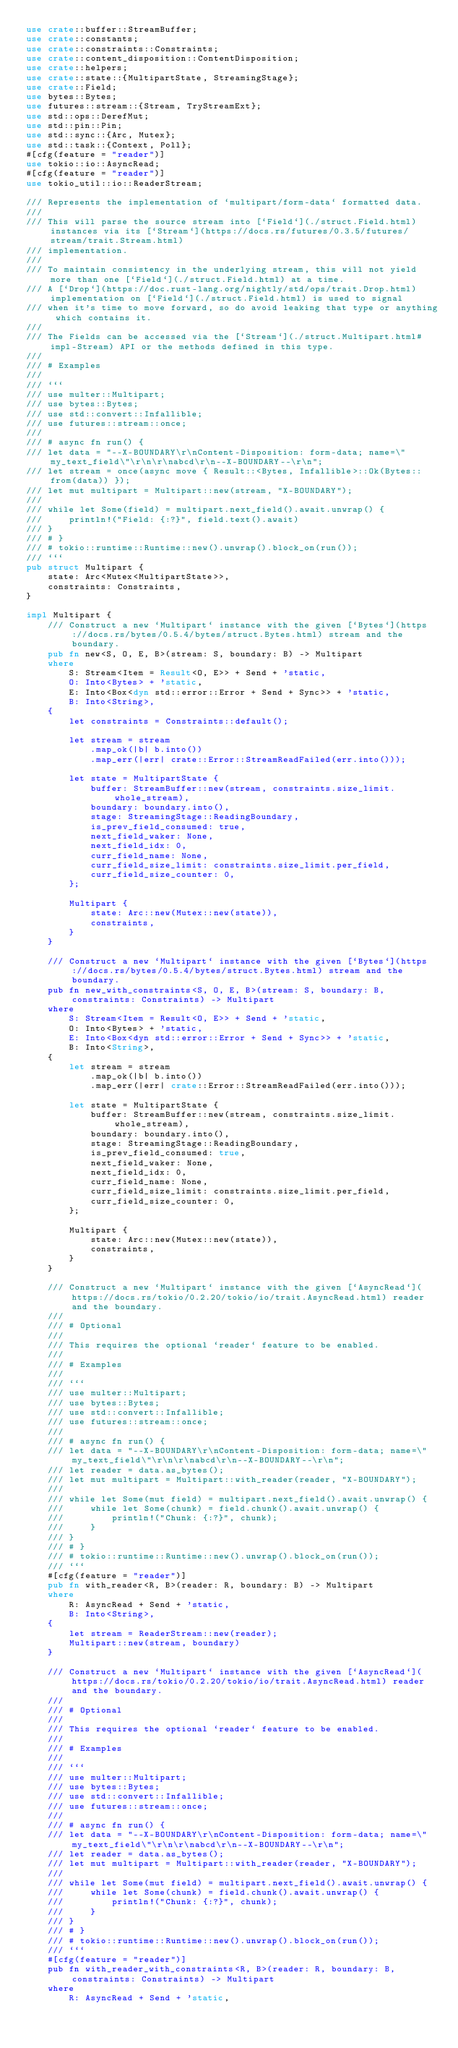<code> <loc_0><loc_0><loc_500><loc_500><_Rust_>use crate::buffer::StreamBuffer;
use crate::constants;
use crate::constraints::Constraints;
use crate::content_disposition::ContentDisposition;
use crate::helpers;
use crate::state::{MultipartState, StreamingStage};
use crate::Field;
use bytes::Bytes;
use futures::stream::{Stream, TryStreamExt};
use std::ops::DerefMut;
use std::pin::Pin;
use std::sync::{Arc, Mutex};
use std::task::{Context, Poll};
#[cfg(feature = "reader")]
use tokio::io::AsyncRead;
#[cfg(feature = "reader")]
use tokio_util::io::ReaderStream;

/// Represents the implementation of `multipart/form-data` formatted data.
///
/// This will parse the source stream into [`Field`](./struct.Field.html) instances via its [`Stream`](https://docs.rs/futures/0.3.5/futures/stream/trait.Stream.html)
/// implementation.
///
/// To maintain consistency in the underlying stream, this will not yield more than one [`Field`](./struct.Field.html) at a time.
/// A [`Drop`](https://doc.rust-lang.org/nightly/std/ops/trait.Drop.html) implementation on [`Field`](./struct.Field.html) is used to signal
/// when it's time to move forward, so do avoid leaking that type or anything which contains it.
///
/// The Fields can be accessed via the [`Stream`](./struct.Multipart.html#impl-Stream) API or the methods defined in this type.
///
/// # Examples
///
/// ```
/// use multer::Multipart;
/// use bytes::Bytes;
/// use std::convert::Infallible;
/// use futures::stream::once;
///
/// # async fn run() {
/// let data = "--X-BOUNDARY\r\nContent-Disposition: form-data; name=\"my_text_field\"\r\n\r\nabcd\r\n--X-BOUNDARY--\r\n";
/// let stream = once(async move { Result::<Bytes, Infallible>::Ok(Bytes::from(data)) });
/// let mut multipart = Multipart::new(stream, "X-BOUNDARY");
///
/// while let Some(field) = multipart.next_field().await.unwrap() {
///     println!("Field: {:?}", field.text().await)
/// }
/// # }
/// # tokio::runtime::Runtime::new().unwrap().block_on(run());
/// ```
pub struct Multipart {
    state: Arc<Mutex<MultipartState>>,
    constraints: Constraints,
}

impl Multipart {
    /// Construct a new `Multipart` instance with the given [`Bytes`](https://docs.rs/bytes/0.5.4/bytes/struct.Bytes.html) stream and the boundary.
    pub fn new<S, O, E, B>(stream: S, boundary: B) -> Multipart
    where
        S: Stream<Item = Result<O, E>> + Send + 'static,
        O: Into<Bytes> + 'static,
        E: Into<Box<dyn std::error::Error + Send + Sync>> + 'static,
        B: Into<String>,
    {
        let constraints = Constraints::default();

        let stream = stream
            .map_ok(|b| b.into())
            .map_err(|err| crate::Error::StreamReadFailed(err.into()));

        let state = MultipartState {
            buffer: StreamBuffer::new(stream, constraints.size_limit.whole_stream),
            boundary: boundary.into(),
            stage: StreamingStage::ReadingBoundary,
            is_prev_field_consumed: true,
            next_field_waker: None,
            next_field_idx: 0,
            curr_field_name: None,
            curr_field_size_limit: constraints.size_limit.per_field,
            curr_field_size_counter: 0,
        };

        Multipart {
            state: Arc::new(Mutex::new(state)),
            constraints,
        }
    }

    /// Construct a new `Multipart` instance with the given [`Bytes`](https://docs.rs/bytes/0.5.4/bytes/struct.Bytes.html) stream and the boundary.
    pub fn new_with_constraints<S, O, E, B>(stream: S, boundary: B, constraints: Constraints) -> Multipart
    where
        S: Stream<Item = Result<O, E>> + Send + 'static,
        O: Into<Bytes> + 'static,
        E: Into<Box<dyn std::error::Error + Send + Sync>> + 'static,
        B: Into<String>,
    {
        let stream = stream
            .map_ok(|b| b.into())
            .map_err(|err| crate::Error::StreamReadFailed(err.into()));

        let state = MultipartState {
            buffer: StreamBuffer::new(stream, constraints.size_limit.whole_stream),
            boundary: boundary.into(),
            stage: StreamingStage::ReadingBoundary,
            is_prev_field_consumed: true,
            next_field_waker: None,
            next_field_idx: 0,
            curr_field_name: None,
            curr_field_size_limit: constraints.size_limit.per_field,
            curr_field_size_counter: 0,
        };

        Multipart {
            state: Arc::new(Mutex::new(state)),
            constraints,
        }
    }

    /// Construct a new `Multipart` instance with the given [`AsyncRead`](https://docs.rs/tokio/0.2.20/tokio/io/trait.AsyncRead.html) reader and the boundary.
    ///
    /// # Optional
    ///
    /// This requires the optional `reader` feature to be enabled.
    ///
    /// # Examples
    ///
    /// ```
    /// use multer::Multipart;
    /// use bytes::Bytes;
    /// use std::convert::Infallible;
    /// use futures::stream::once;
    ///
    /// # async fn run() {
    /// let data = "--X-BOUNDARY\r\nContent-Disposition: form-data; name=\"my_text_field\"\r\n\r\nabcd\r\n--X-BOUNDARY--\r\n";
    /// let reader = data.as_bytes();
    /// let mut multipart = Multipart::with_reader(reader, "X-BOUNDARY");
    ///
    /// while let Some(mut field) = multipart.next_field().await.unwrap() {
    ///     while let Some(chunk) = field.chunk().await.unwrap() {
    ///         println!("Chunk: {:?}", chunk);
    ///     }
    /// }
    /// # }
    /// # tokio::runtime::Runtime::new().unwrap().block_on(run());
    /// ```
    #[cfg(feature = "reader")]
    pub fn with_reader<R, B>(reader: R, boundary: B) -> Multipart
    where
        R: AsyncRead + Send + 'static,
        B: Into<String>,
    {
        let stream = ReaderStream::new(reader);
        Multipart::new(stream, boundary)
    }

    /// Construct a new `Multipart` instance with the given [`AsyncRead`](https://docs.rs/tokio/0.2.20/tokio/io/trait.AsyncRead.html) reader and the boundary.
    ///
    /// # Optional
    ///
    /// This requires the optional `reader` feature to be enabled.
    ///
    /// # Examples
    ///
    /// ```
    /// use multer::Multipart;
    /// use bytes::Bytes;
    /// use std::convert::Infallible;
    /// use futures::stream::once;
    ///
    /// # async fn run() {
    /// let data = "--X-BOUNDARY\r\nContent-Disposition: form-data; name=\"my_text_field\"\r\n\r\nabcd\r\n--X-BOUNDARY--\r\n";
    /// let reader = data.as_bytes();
    /// let mut multipart = Multipart::with_reader(reader, "X-BOUNDARY");
    ///
    /// while let Some(mut field) = multipart.next_field().await.unwrap() {
    ///     while let Some(chunk) = field.chunk().await.unwrap() {
    ///         println!("Chunk: {:?}", chunk);
    ///     }
    /// }
    /// # }
    /// # tokio::runtime::Runtime::new().unwrap().block_on(run());
    /// ```
    #[cfg(feature = "reader")]
    pub fn with_reader_with_constraints<R, B>(reader: R, boundary: B, constraints: Constraints) -> Multipart
    where
        R: AsyncRead + Send + 'static,</code> 